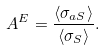Convert formula to latex. <formula><loc_0><loc_0><loc_500><loc_500>A ^ { E } = \frac { \langle \sigma _ { a S } \rangle } { \langle \sigma _ { S } \rangle } .</formula> 